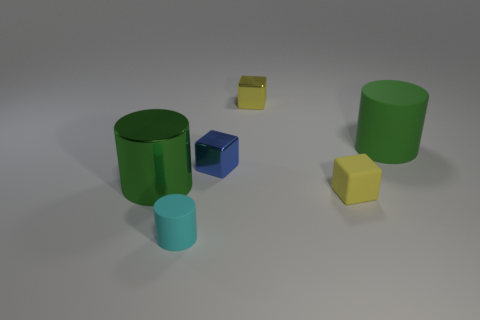How many other objects are the same shape as the cyan object?
Make the answer very short. 2. What number of metal things are either blue cubes or green cylinders?
Keep it short and to the point. 2. Are there any cyan cylinders made of the same material as the cyan object?
Provide a succinct answer. No. What number of matte cylinders are both to the left of the yellow matte object and to the right of the cyan object?
Make the answer very short. 0. Is the number of cyan objects that are in front of the tiny cylinder less than the number of large green objects on the left side of the large green matte cylinder?
Offer a very short reply. Yes. Does the blue object have the same shape as the yellow matte thing?
Provide a short and direct response. Yes. What number of other things are there of the same size as the cyan cylinder?
Make the answer very short. 3. How many things are either green things left of the cyan matte thing or objects behind the cyan matte cylinder?
Your answer should be very brief. 5. What number of other metal objects are the same shape as the small yellow shiny object?
Keep it short and to the point. 1. The small object that is in front of the big metal thing and behind the small rubber cylinder is made of what material?
Provide a succinct answer. Rubber. 